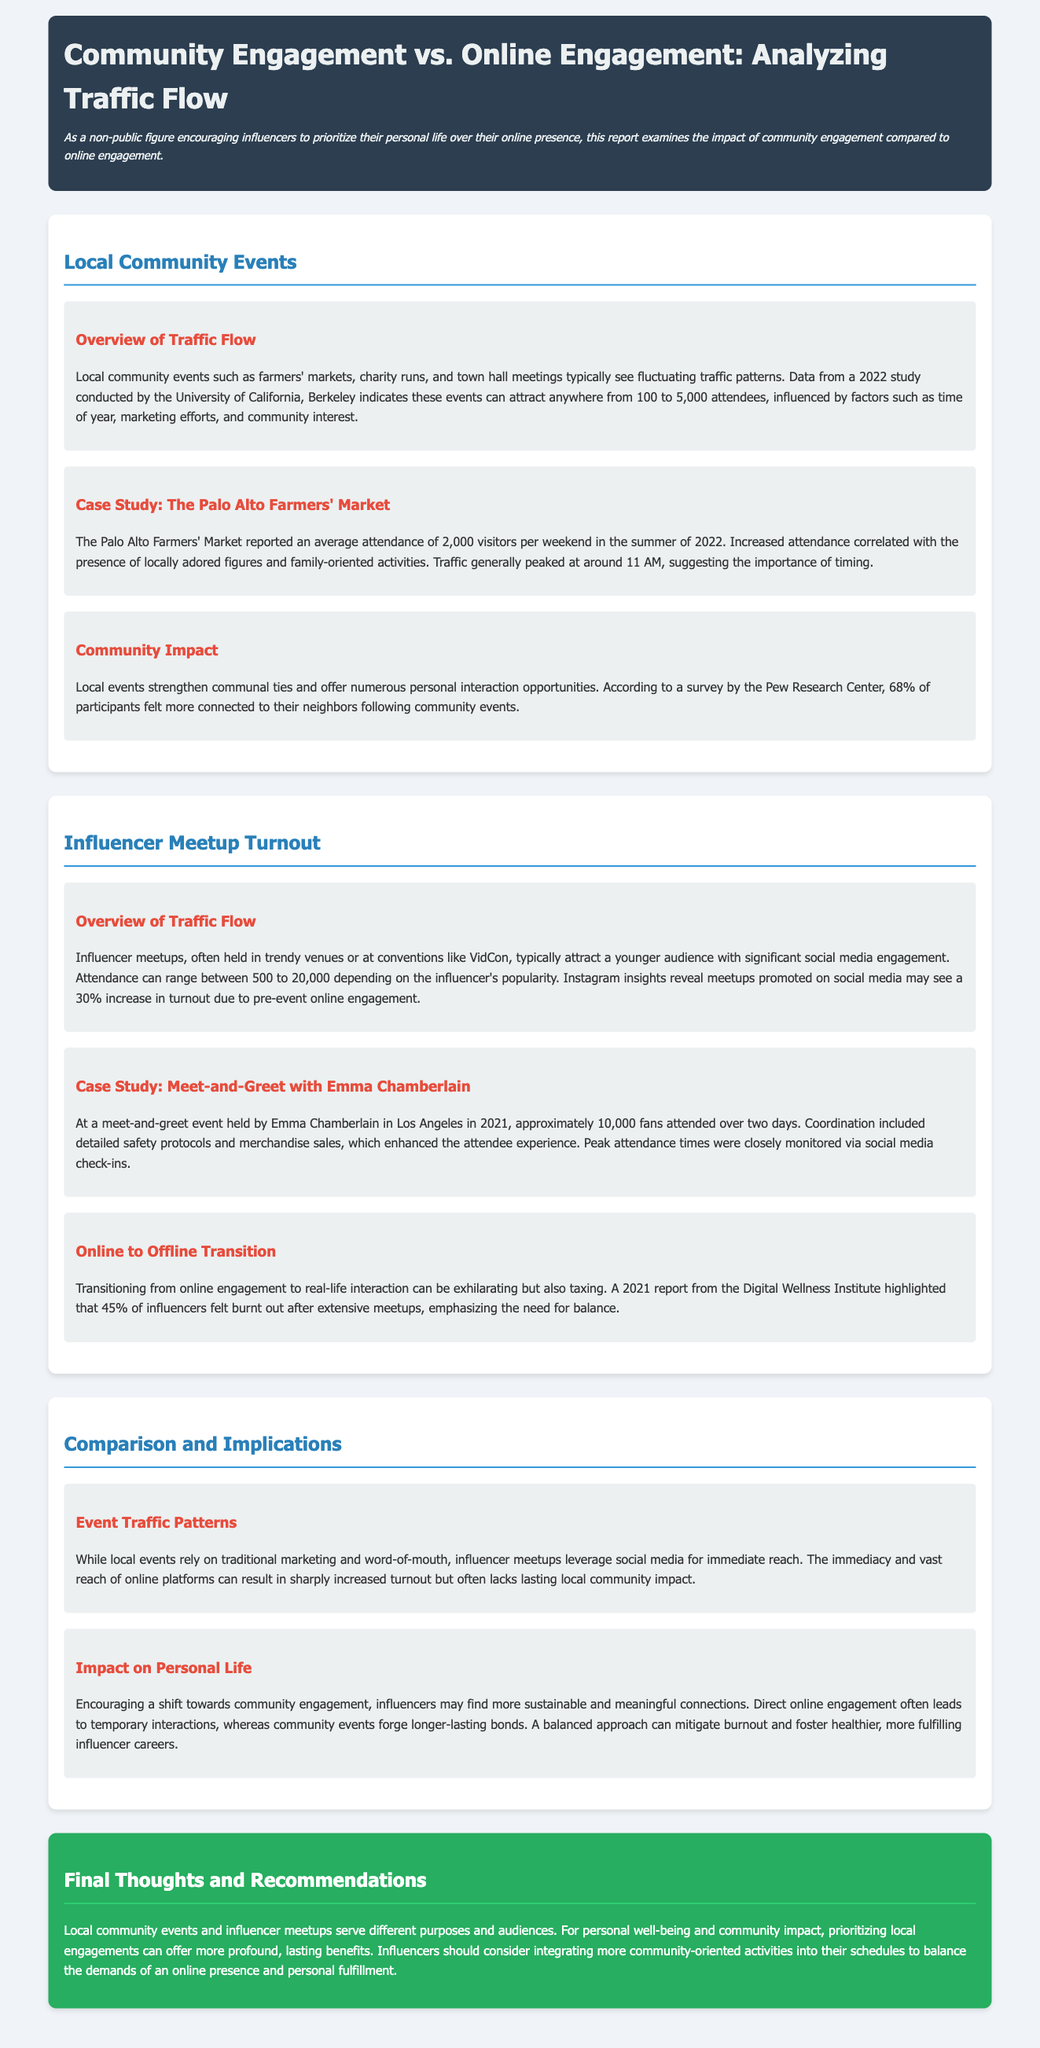What is the maximum attendance for local community events? The document states that local community events can attract anywhere from 100 to 5,000 attendees.
Answer: 5,000 What average attendance was reported for the Palo Alto Farmers' Market? The report indicates that the Palo Alto Farmers' Market had an average attendance of 2,000 visitors per weekend.
Answer: 2,000 Which social media platform shows a 30% increase in turnout for influencer meetups? The document mentions that Instagram insights reveal a 30% increase due to pre-event online engagement.
Answer: Instagram What was the attendance at Emma Chamberlain's meet-and-greet event? The case study states that approximately 10,000 fans attended the meet-and-greet event.
Answer: 10,000 What percentage of influencers felt burnt out after extensive meetups? According to the Digital Wellness Institute report, 45% of influencers felt burnt out.
Answer: 45% How do local events primarily attract attendees compared to influencer meetups? Local events rely on traditional marketing and word-of-mouth, while influencer meetups leverage social media for immediate reach.
Answer: Traditional marketing and word-of-mouth What was the average attendance reported during the summer of 2022 at the Palo Alto Farmers' Market? The report specifies the average attendance during summer 2022 as 2,000 visitors.
Answer: 2,000 What is the key benefit of community events according to the Pew Research Center? The survey by the Pew Research Center found that 68% of participants felt more connected to their neighbors after community events.
Answer: 68% 